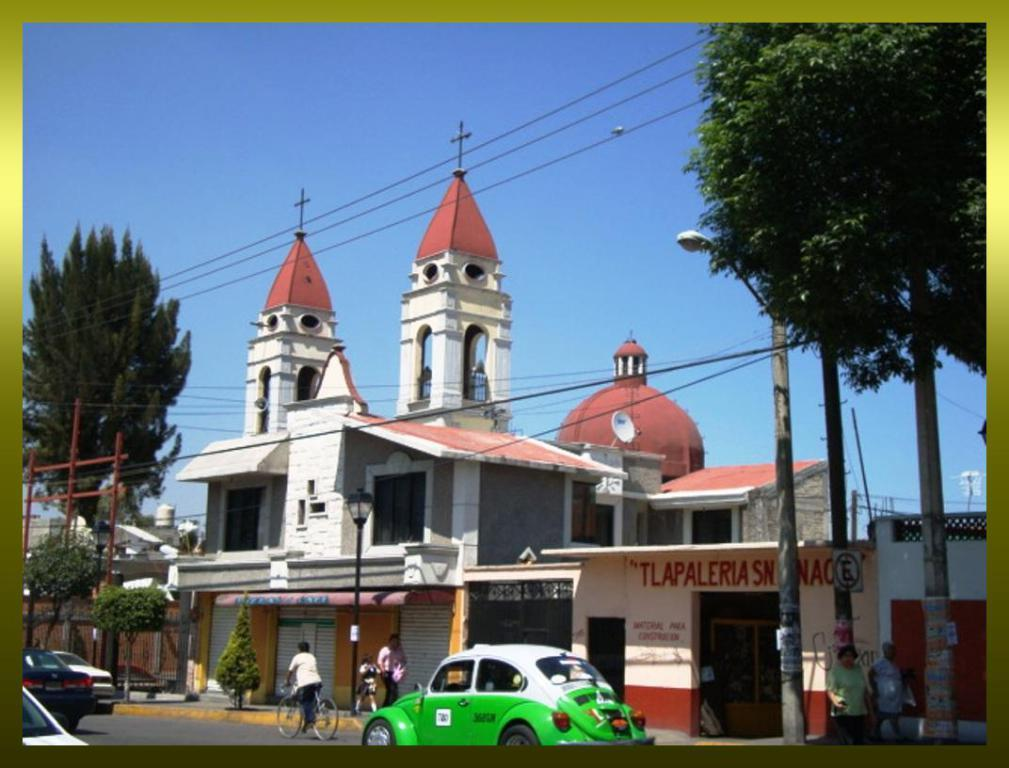What can be seen moving on the road in the image? There are vehicles on the road in the image. Are there any living beings present in the image? Yes, there are people in the image. What type of structures can be seen in the image? There are poles and buildings visible in the image. What else can be seen in the image besides the vehicles and people? There are trees, wires, and buildings in the background of the image. Can you see a net being used by the people in the image? There is no net present in the image. How many hands are visible in the image? The number of hands cannot be determined from the image, as it only shows people from a distance. 